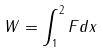Convert formula to latex. <formula><loc_0><loc_0><loc_500><loc_500>W = \int _ { 1 } ^ { 2 } F d x</formula> 